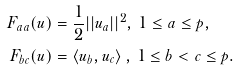<formula> <loc_0><loc_0><loc_500><loc_500>F _ { a a } ( { u } ) & = \frac { 1 } { 2 } | | { u } _ { a } | | ^ { 2 } , \, 1 \leq a \leq p , \\ F _ { b c } ( { u } ) & = \left < { u } _ { b } , { u } _ { c } \right > , \, 1 \leq b < c \leq p .</formula> 